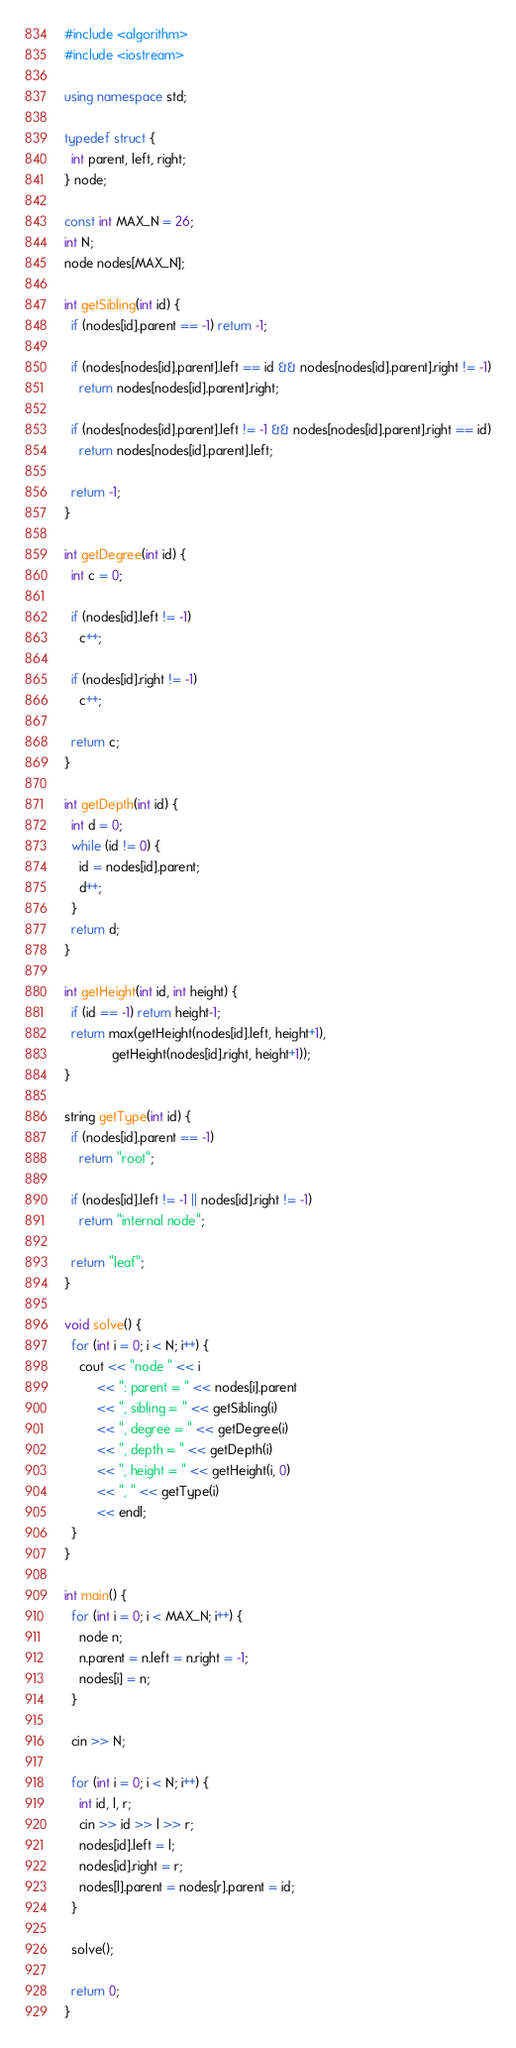Convert code to text. <code><loc_0><loc_0><loc_500><loc_500><_C++_>#include <algorithm>
#include <iostream>

using namespace std;

typedef struct {
  int parent, left, right;
} node;

const int MAX_N = 26;
int N;
node nodes[MAX_N];

int getSibling(int id) {
  if (nodes[id].parent == -1) return -1;

  if (nodes[nodes[id].parent].left == id && nodes[nodes[id].parent].right != -1)
    return nodes[nodes[id].parent].right;

  if (nodes[nodes[id].parent].left != -1 && nodes[nodes[id].parent].right == id)
    return nodes[nodes[id].parent].left;

  return -1;
}

int getDegree(int id) {
  int c = 0;

  if (nodes[id].left != -1)
    c++;

  if (nodes[id].right != -1)
    c++;

  return c;
}

int getDepth(int id) {
  int d = 0;
  while (id != 0) {
    id = nodes[id].parent;
    d++;
  }
  return d;
}

int getHeight(int id, int height) {
  if (id == -1) return height-1;
  return max(getHeight(nodes[id].left, height+1),
             getHeight(nodes[id].right, height+1));
}

string getType(int id) {
  if (nodes[id].parent == -1)
    return "root";

  if (nodes[id].left != -1 || nodes[id].right != -1)
    return "internal node";

  return "leaf";
}

void solve() {
  for (int i = 0; i < N; i++) {
    cout << "node " << i
         << ": parent = " << nodes[i].parent
         << ", sibling = " << getSibling(i)
         << ", degree = " << getDegree(i)
         << ", depth = " << getDepth(i)
         << ", height = " << getHeight(i, 0)
         << ", " << getType(i)
         << endl;
  }
}

int main() {
  for (int i = 0; i < MAX_N; i++) {
    node n;
    n.parent = n.left = n.right = -1;
    nodes[i] = n;
  }

  cin >> N;

  for (int i = 0; i < N; i++) {
    int id, l, r;
    cin >> id >> l >> r;
    nodes[id].left = l;
    nodes[id].right = r;
    nodes[l].parent = nodes[r].parent = id;
  }

  solve();

  return 0;
}</code> 